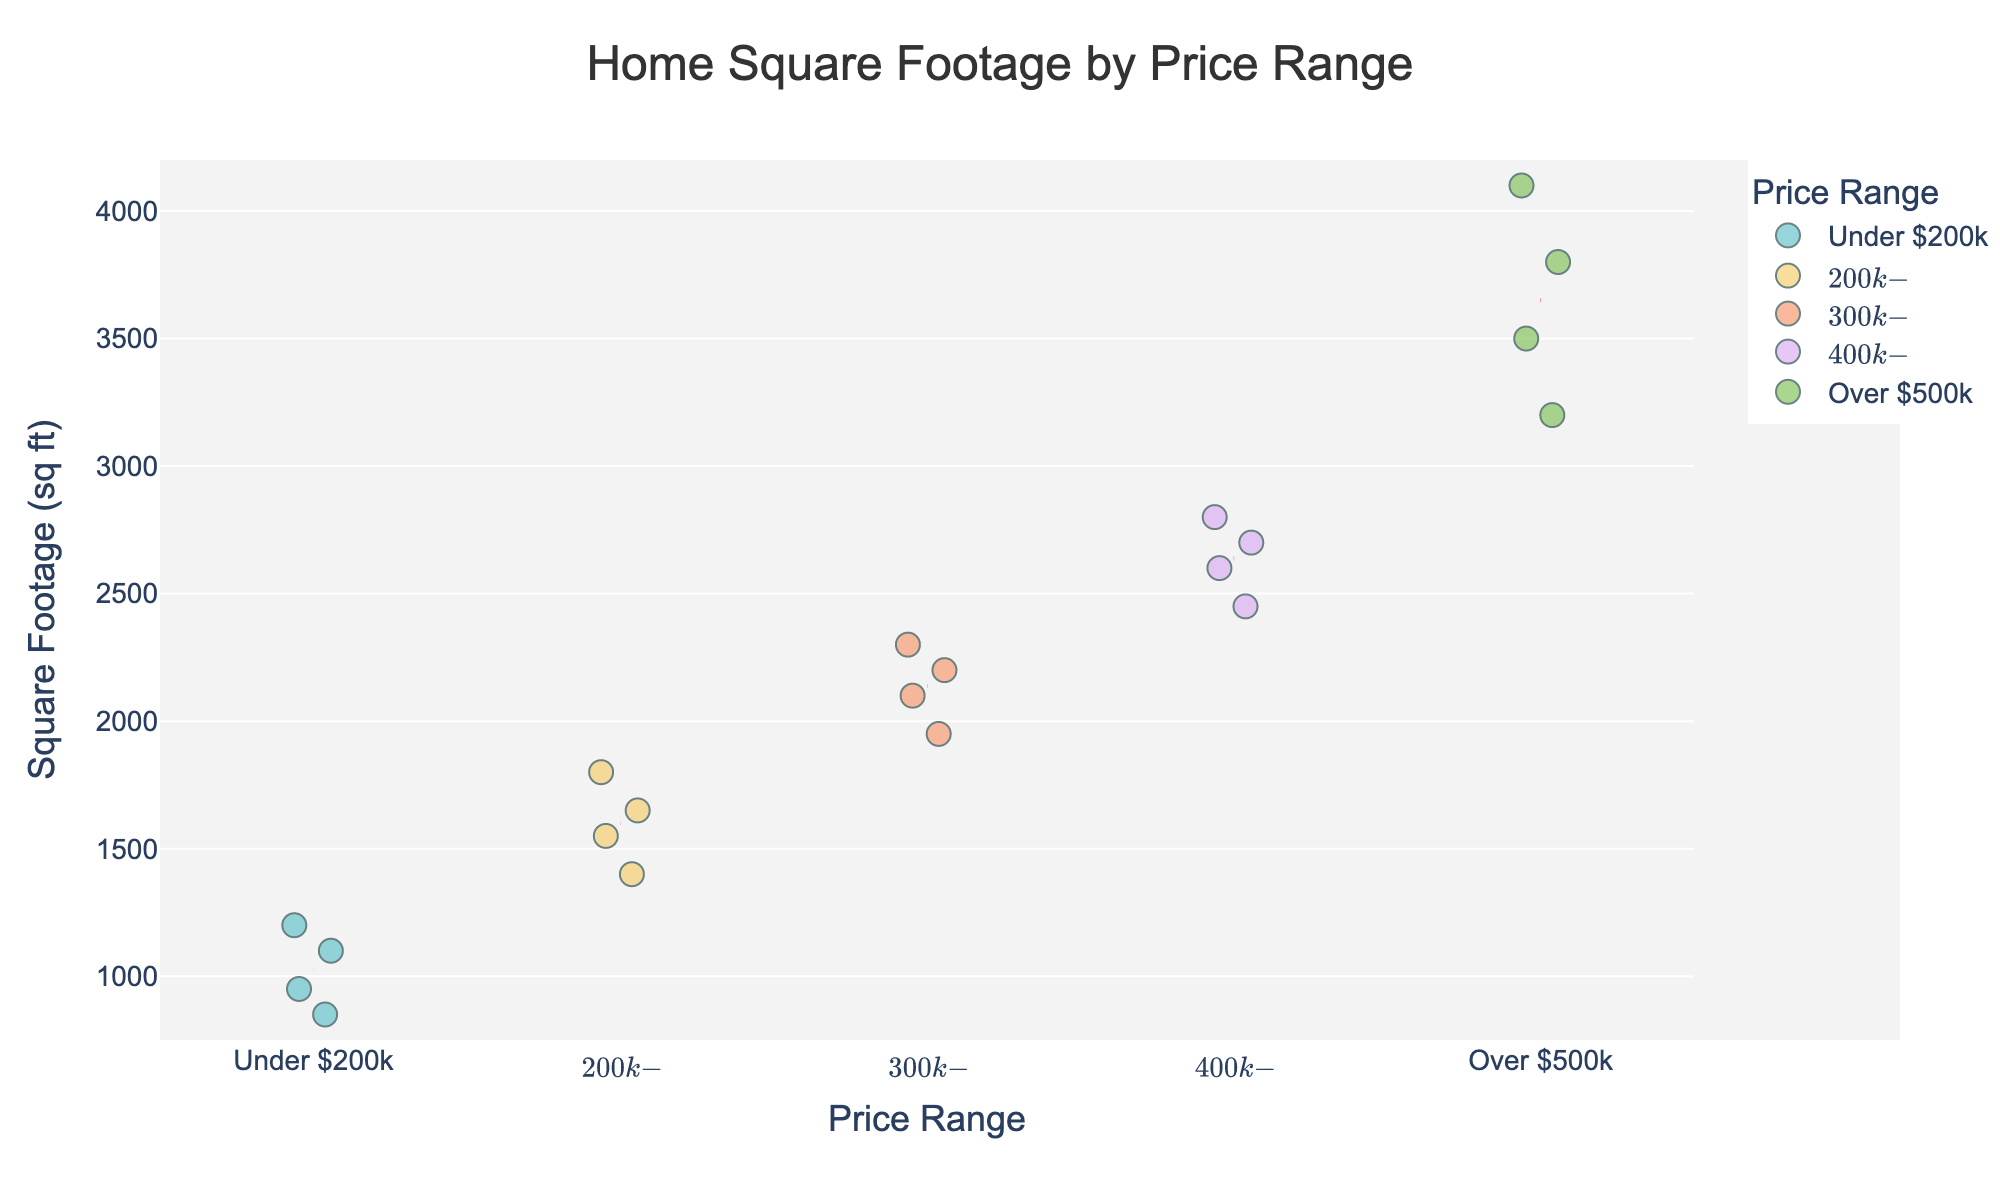What is the title of the figure? The title is usually placed at the top of a figure and describes what the figure is about.
Answer: Home Square Footage by Price Range How many price ranges are displayed in the figure? The x-axis in the strip plot shows the different price ranges. Count the distinct categories.
Answer: 5 What is the range of square footage shown on the y-axis? Look at the y-axis, which lists the minimum and maximum values for square footage.
Answer: 750 to 4200 sq ft Which price range has the highest average square footage? The price range with the highest average square footage is indicated by the highest red dashed line in the figure.
Answer: Over $500k How many homes are in the $200k-$300k range? Count the number of data points (marks) within the $200k-$300k range on the strip plot.
Answer: 4 Which price range shows the most variation in square footage? The price range with the largest spread of data points on the y-axis has the most variation.
Answer: Over $500k What is the minimum square footage in the 'Under $200k' range? Identify the lowest data point in the 'Under $200k' price range on the y-axis.
Answer: 850 sq ft Compare the maximum square footage in the $300k-$400k range to that in the $400k-$500k range. Identify the highest data point for both price ranges and compare their values.
Answer: $400k-$500k range is higher Is there any price range where all homes have a square footage below 2000 sq ft? Check each price range to see if all data points (markings) on the y-axis are below the 2000 sq ft line.
Answer: Under $200k 